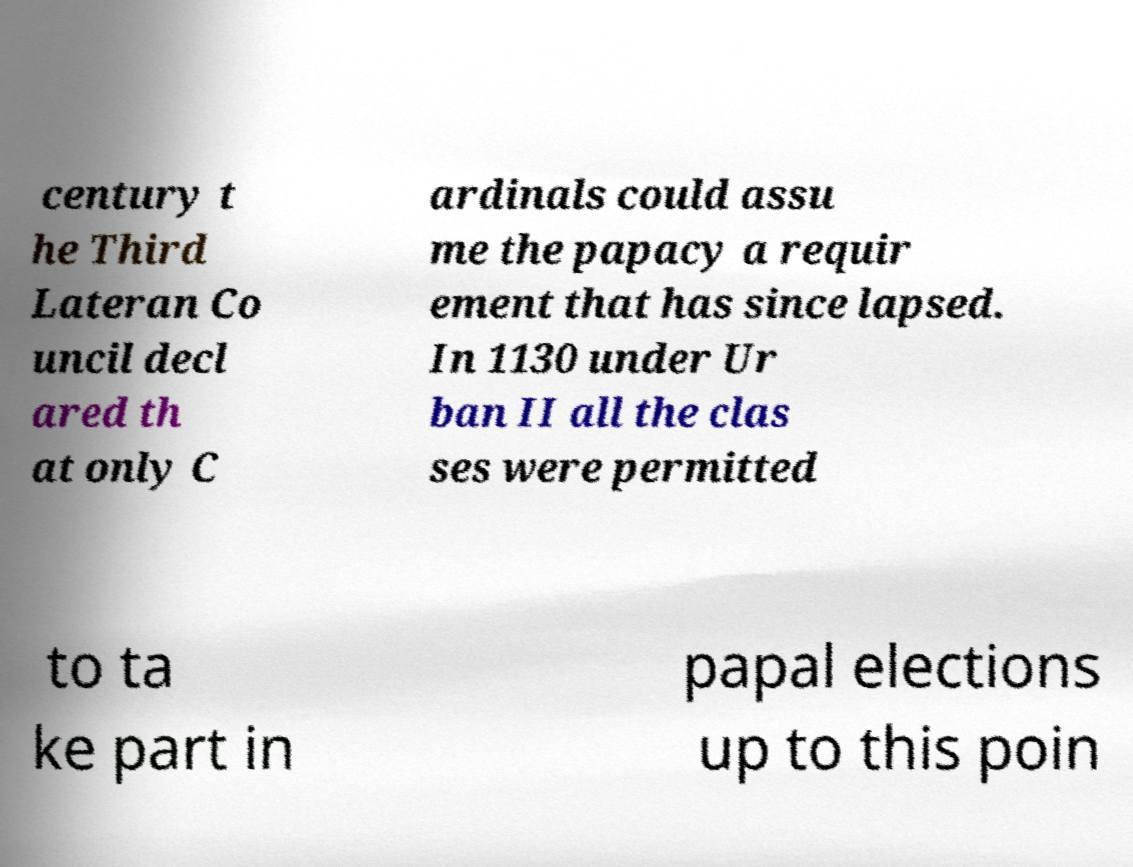For documentation purposes, I need the text within this image transcribed. Could you provide that? century t he Third Lateran Co uncil decl ared th at only C ardinals could assu me the papacy a requir ement that has since lapsed. In 1130 under Ur ban II all the clas ses were permitted to ta ke part in papal elections up to this poin 